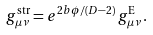<formula> <loc_0><loc_0><loc_500><loc_500>g _ { \mu \nu } ^ { \text {str} } = e ^ { 2 b \phi / ( D - 2 ) } \, g _ { \mu \nu } ^ { \text {E} } \, .</formula> 